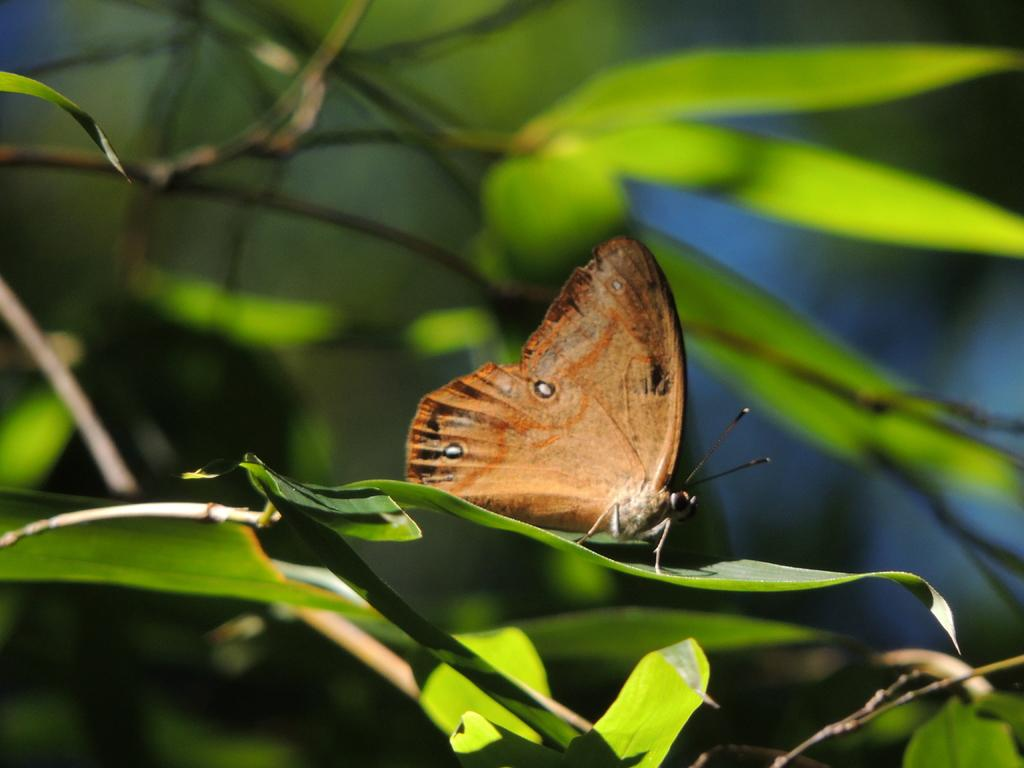What is the main subject of the image? The main subject of the image is a butterfly on a leaf. What else can be seen in the image besides the butterfly? There is a plant in the image. How many bikes are parked in the room in the image? There is no room or bikes present in the image; it features a butterfly on a leaf and a plant. 